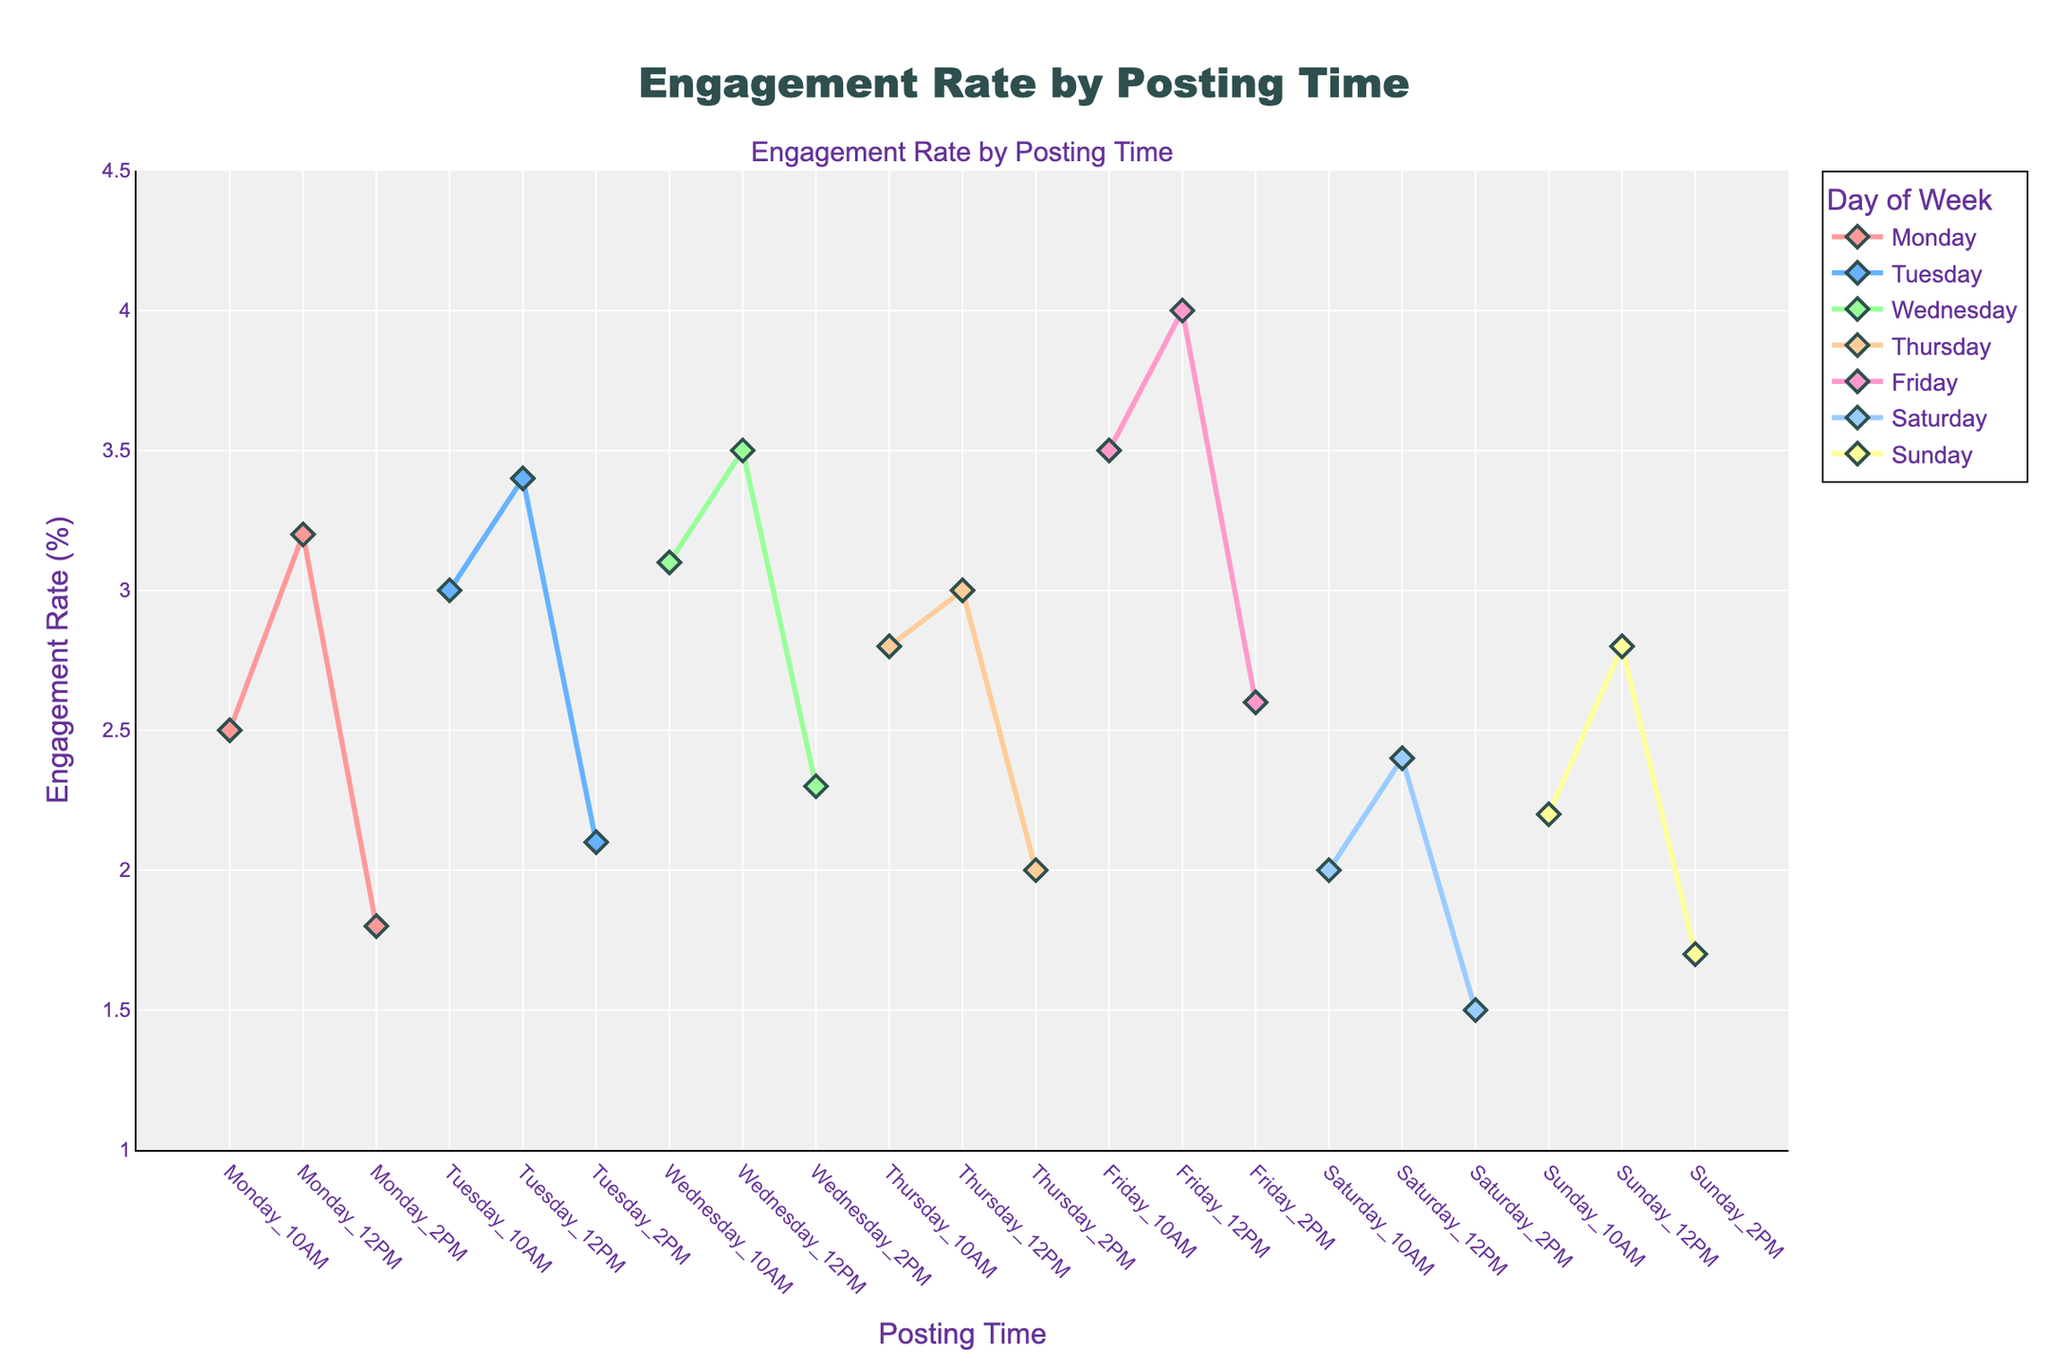How many different posting times are analyzed in the figure? There are seven weekdays and three different times per day (10 AM, 12 PM, 2 PM). Multiplying these gives 7 * 3 = 21 different posting times.
Answer: 21 What are the colors used to represent the days, and which days do they correspond to? The colors used are specified as follows: Monday (#FF9999), Tuesday (#66B2FF), Wednesday (#99FF99), Thursday (#FFCC99), Friday (#FF99CC), Saturday (#99CCFF), and Sunday (#FFFF99).
Answer: Various colors corresponding to days Which day and time combination has the highest engagement rate? By observing the plot, Friday at 12 PM has the highest engagement rate of 4.0%.
Answer: Friday 12 PM Which day and time combination has the lowest engagement rate? By observing the plot, Saturday at 2 PM has the lowest engagement rate of 1.5%.
Answer: Saturday 2 PM What is the average engagement rate for posts on Mondays? Monday's engagement rates are 2.5, 3.2, and 1.8. The average is calculated as (2.5 + 3.2 + 1.8) / 3 ≈ 2.5%.
Answer: 2.5% Compare the engagement rates on Wednesday at 10 AM and Thursday at 12 PM. Which one is higher? By observing the plot, Wednesday at 10 AM has an engagement rate of 3.1%, and Thursday at 12 PM has an engagement rate of 3.0%. Therefore, Wednesday at 10 AM is higher.
Answer: Wednesday 10 AM Between 10 AM and 2 PM posting times, which time results in higher overall engagement rates throughout the week? Summing the engagement rates for 10 AM posts throughout the week and doing the same for 2 PM posts, then comparing the totals. 10 AM daily totals: 2.5+3.0+3.1+2.8+3.5+2.0+2.2 = 19.1. 2 PM daily totals: 1.8+2.1+2.3+2.0+2.6+1.5+1.7 = 14.0. Therefore, 10 AM has a higher overall engagement rate.
Answer: 10 AM Is there a pattern in engagement rates based on days of the week? If so, what is it? By observing the plot, there is a trend where engagement rates are generally higher on weekdays (Monday to Friday) than on weekends (Saturday and Sunday).
Answer: Higher on weekdays Which posting time on Wednesday has the highest engagement rate, and what is it? By observing the plot, Wednesday at 12 PM has the highest engagement rate of 3.5%.
Answer: Wednesday 12 PM 